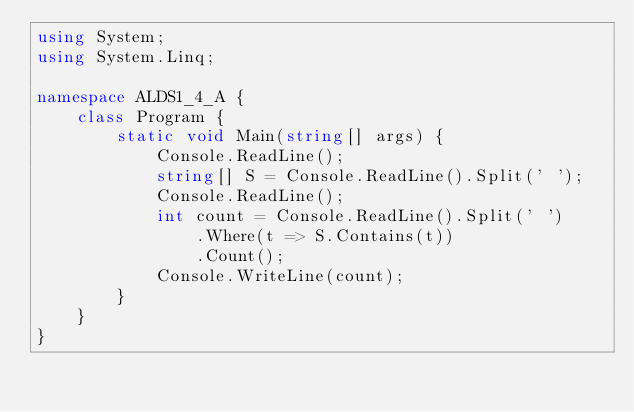<code> <loc_0><loc_0><loc_500><loc_500><_C#_>using System;
using System.Linq;

namespace ALDS1_4_A {
    class Program {
        static void Main(string[] args) {
            Console.ReadLine();
            string[] S = Console.ReadLine().Split(' ');
            Console.ReadLine();
            int count = Console.ReadLine().Split(' ')
                .Where(t => S.Contains(t))
                .Count();
            Console.WriteLine(count);
        }
    }
}</code> 